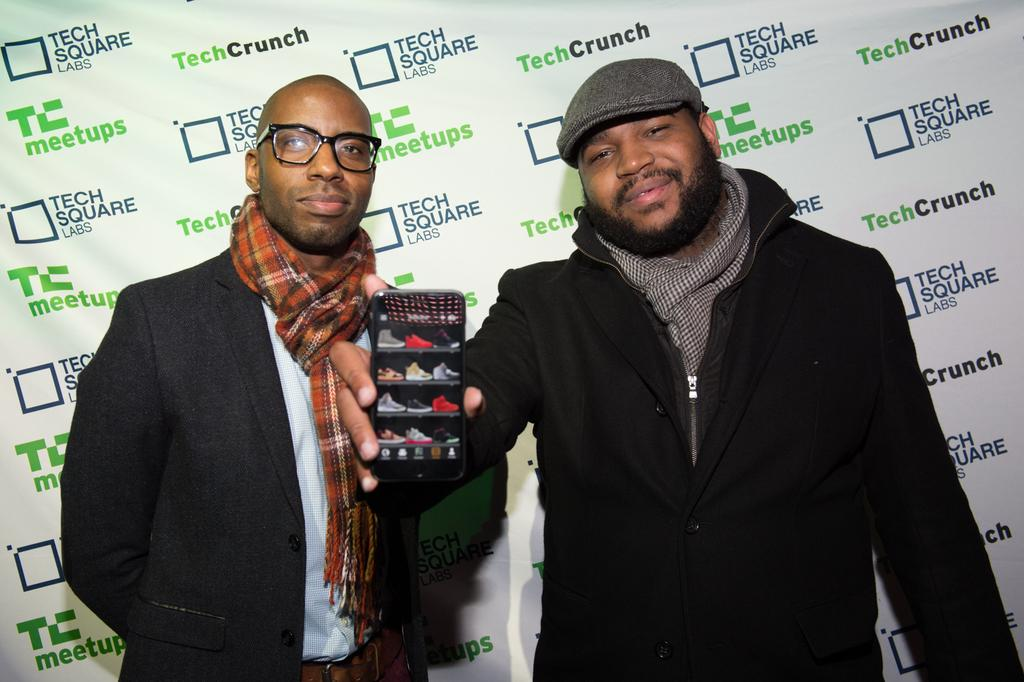What is the man in the image holding? The man is holding a phone in the image. Can you describe the other person in the image? There is another man beside him in the image. What can be seen in the background of the image? There appears to be a poster in the background of the image. What type of farm can be seen in the background of the image? There is no farm present in the image; it features a poster in the background. How many volleyballs are visible in the image? There are no volleyballs visible in the image. 